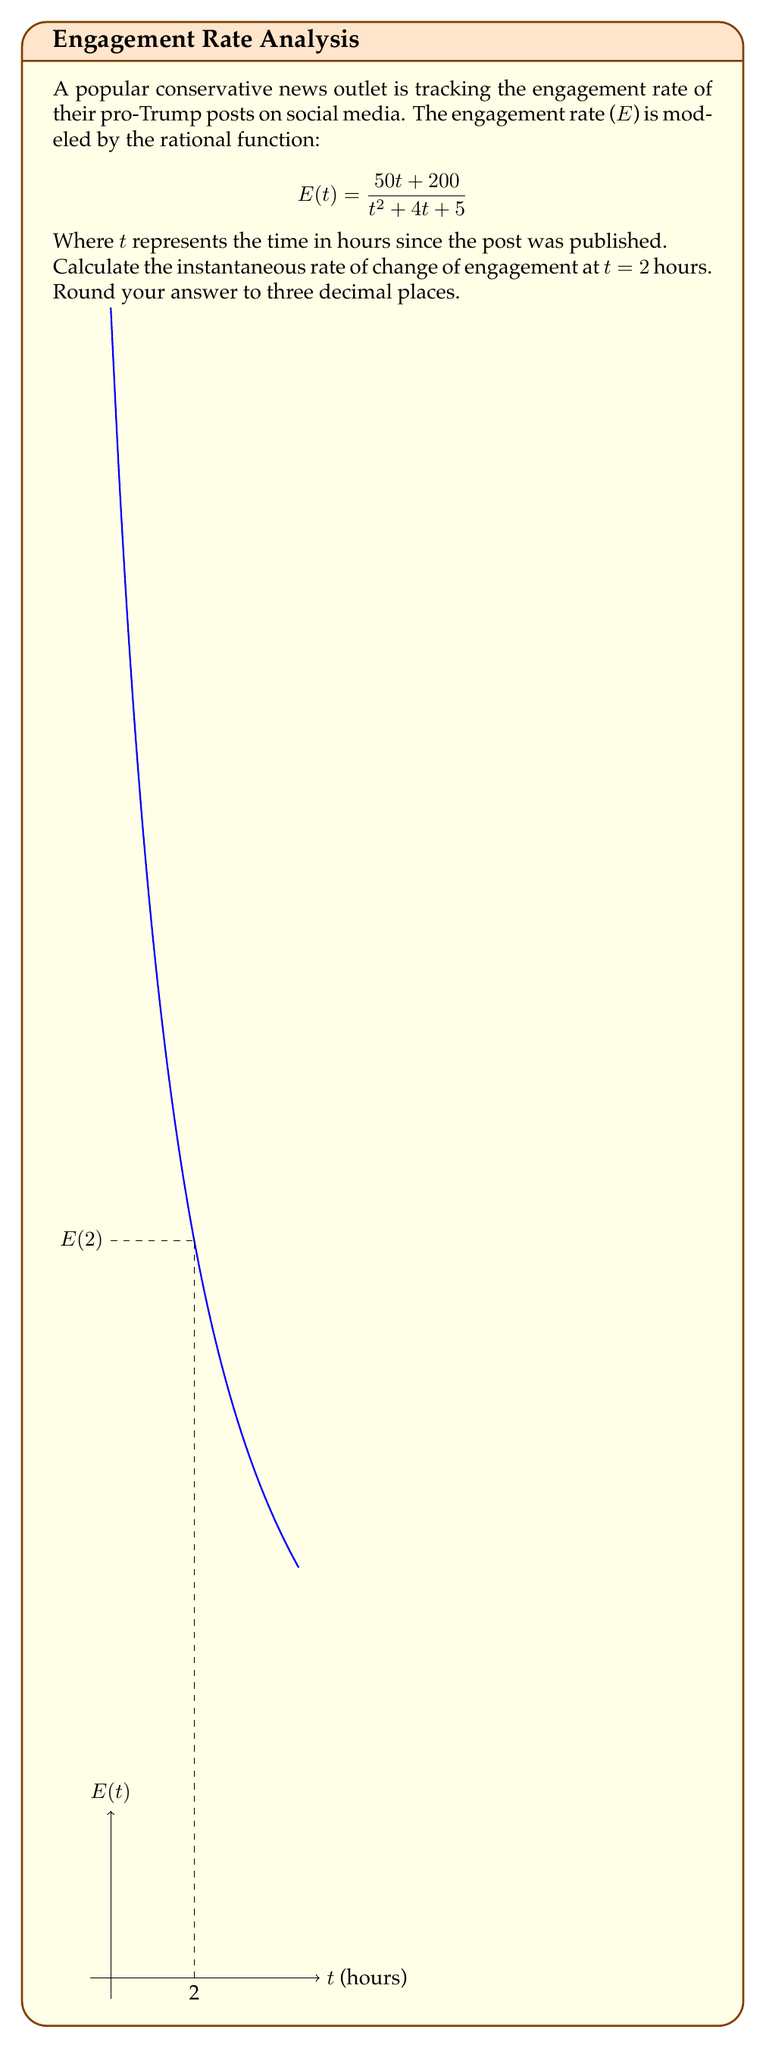Show me your answer to this math problem. To find the instantaneous rate of change at t = 2, we need to calculate the derivative of E(t) and evaluate it at t = 2.

Step 1: Calculate the derivative of E(t) using the quotient rule.
Let $u = 50t + 200$ and $v = t^2 + 4t + 5$

$$E'(t) = \frac{u'v - uv'}{v^2}$$

$u' = 50$
$v' = 2t + 4$

$$E'(t) = \frac{50(t^2 + 4t + 5) - (50t + 200)(2t + 4)}{(t^2 + 4t + 5)^2}$$

Step 2: Simplify the numerator
$$E'(t) = \frac{50t^2 + 200t + 250 - 100t^2 - 400t - 400t - 800}{(t^2 + 4t + 5)^2}$$
$$E'(t) = \frac{-50t^2 - 600t - 550}{(t^2 + 4t + 5)^2}$$

Step 3: Evaluate E'(t) at t = 2
$$E'(2) = \frac{-50(2)^2 - 600(2) - 550}{(2^2 + 4(2) + 5)^2}$$
$$E'(2) = \frac{-200 - 1200 - 550}{(4 + 8 + 5)^2}$$
$$E'(2) = \frac{-1950}{17^2}$$
$$E'(2) = \frac{-1950}{289}$$
$$E'(2) \approx -6.747$$

Step 4: Round to three decimal places
$$E'(2) \approx -6.747$$
Answer: -6.747 